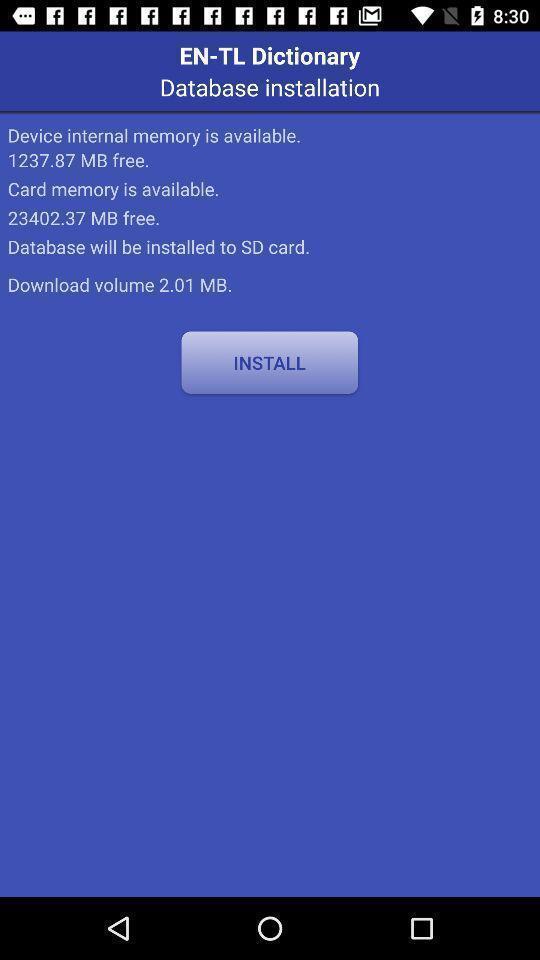What can you discern from this picture? Page showing information about internal storage. 